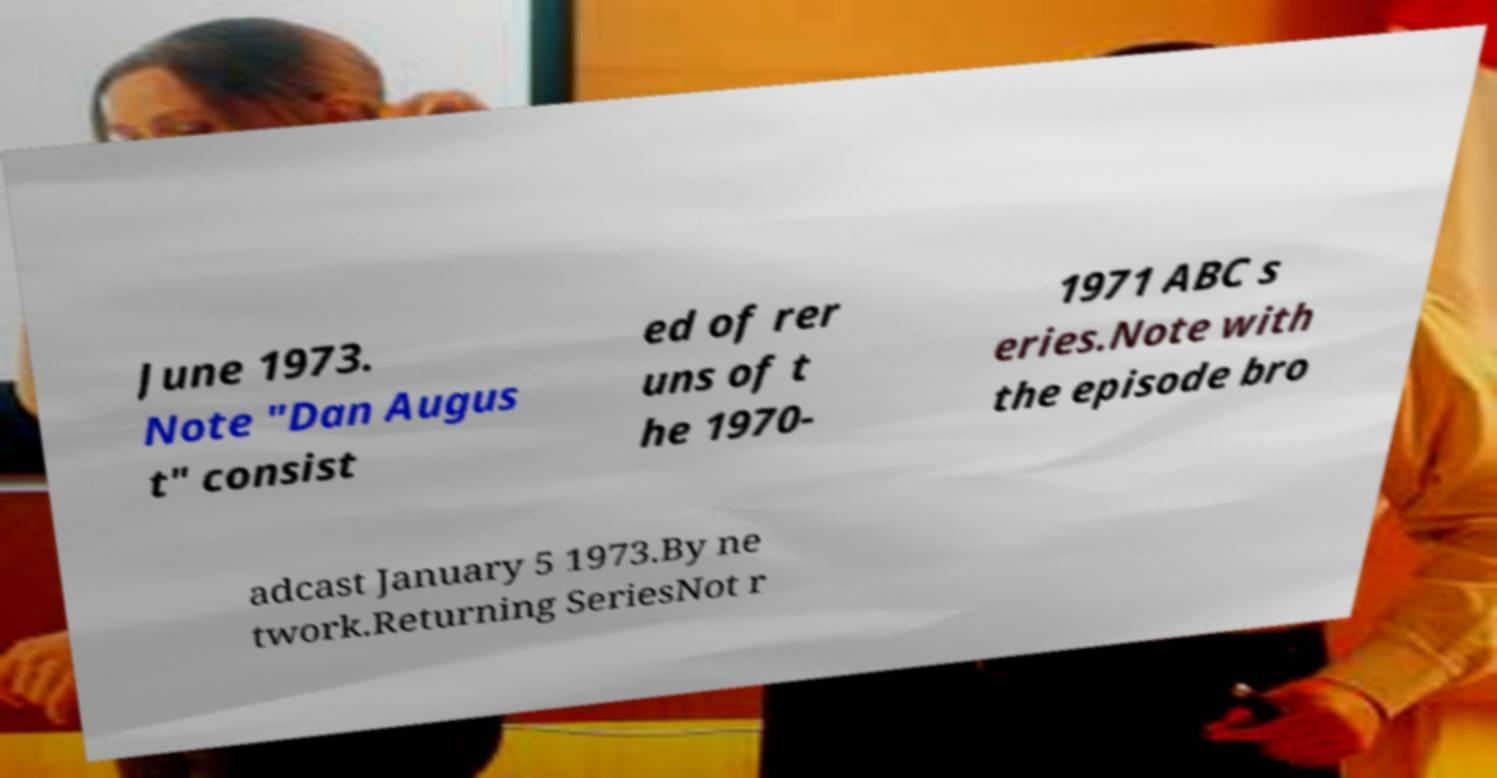Could you assist in decoding the text presented in this image and type it out clearly? June 1973. Note "Dan Augus t" consist ed of rer uns of t he 1970- 1971 ABC s eries.Note with the episode bro adcast January 5 1973.By ne twork.Returning SeriesNot r 